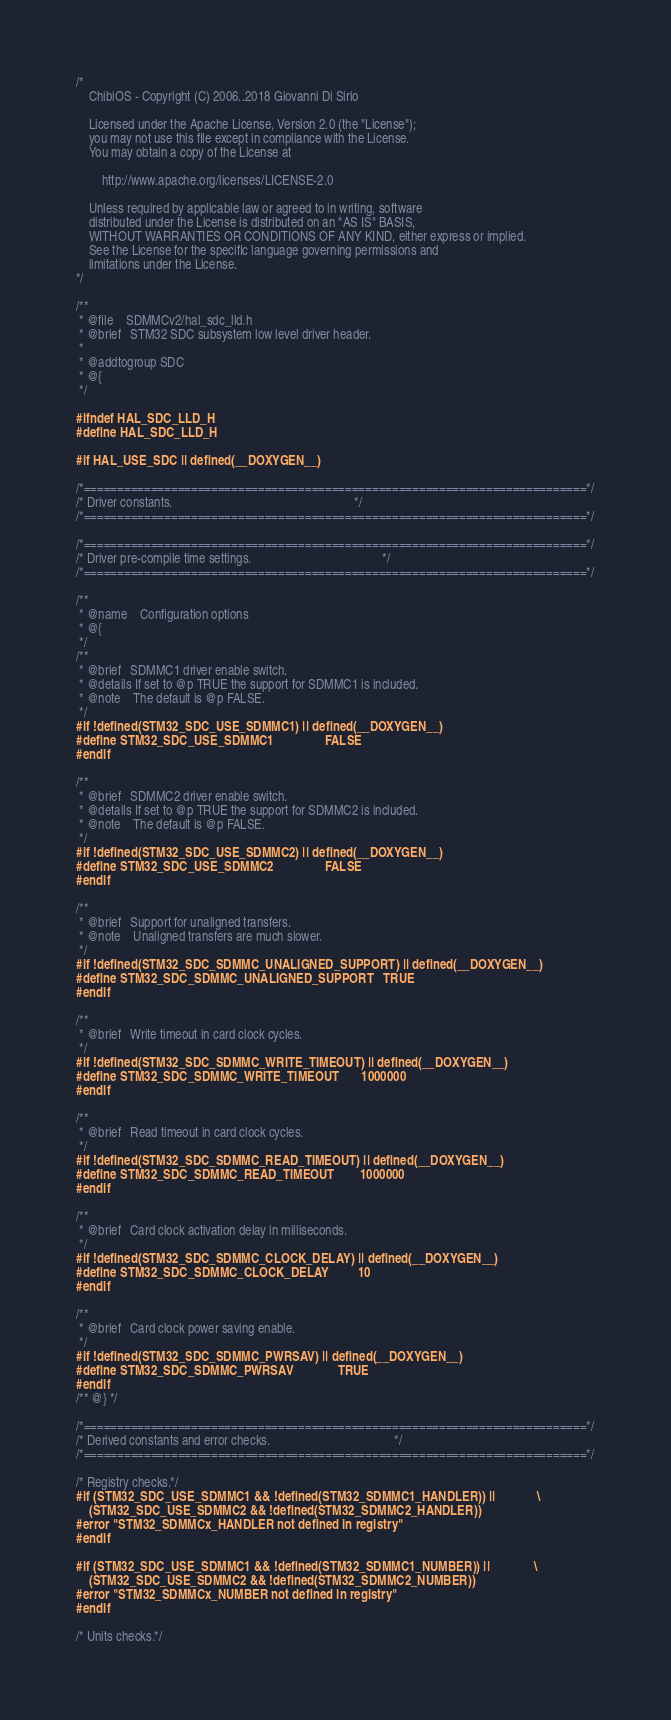Convert code to text. <code><loc_0><loc_0><loc_500><loc_500><_C_>/*
    ChibiOS - Copyright (C) 2006..2018 Giovanni Di Sirio

    Licensed under the Apache License, Version 2.0 (the "License");
    you may not use this file except in compliance with the License.
    You may obtain a copy of the License at

        http://www.apache.org/licenses/LICENSE-2.0

    Unless required by applicable law or agreed to in writing, software
    distributed under the License is distributed on an "AS IS" BASIS,
    WITHOUT WARRANTIES OR CONDITIONS OF ANY KIND, either express or implied.
    See the License for the specific language governing permissions and
    limitations under the License.
*/

/**
 * @file    SDMMCv2/hal_sdc_lld.h
 * @brief   STM32 SDC subsystem low level driver header.
 *
 * @addtogroup SDC
 * @{
 */

#ifndef HAL_SDC_LLD_H
#define HAL_SDC_LLD_H

#if HAL_USE_SDC || defined(__DOXYGEN__)

/*===========================================================================*/
/* Driver constants.                                                         */
/*===========================================================================*/

/*===========================================================================*/
/* Driver pre-compile time settings.                                         */
/*===========================================================================*/

/**
 * @name    Configuration options
 * @{
 */
/**
 * @brief   SDMMC1 driver enable switch.
 * @details If set to @p TRUE the support for SDMMC1 is included.
 * @note    The default is @p FALSE.
 */
#if !defined(STM32_SDC_USE_SDMMC1) || defined(__DOXYGEN__)
#define STM32_SDC_USE_SDMMC1                FALSE
#endif

/**
 * @brief   SDMMC2 driver enable switch.
 * @details If set to @p TRUE the support for SDMMC2 is included.
 * @note    The default is @p FALSE.
 */
#if !defined(STM32_SDC_USE_SDMMC2) || defined(__DOXYGEN__)
#define STM32_SDC_USE_SDMMC2                FALSE
#endif

/**
 * @brief   Support for unaligned transfers.
 * @note    Unaligned transfers are much slower.
 */
#if !defined(STM32_SDC_SDMMC_UNALIGNED_SUPPORT) || defined(__DOXYGEN__)
#define STM32_SDC_SDMMC_UNALIGNED_SUPPORT   TRUE
#endif

/**
 * @brief   Write timeout in card clock cycles.
 */
#if !defined(STM32_SDC_SDMMC_WRITE_TIMEOUT) || defined(__DOXYGEN__)
#define STM32_SDC_SDMMC_WRITE_TIMEOUT       1000000
#endif

/**
 * @brief   Read timeout in card clock cycles.
 */
#if !defined(STM32_SDC_SDMMC_READ_TIMEOUT) || defined(__DOXYGEN__)
#define STM32_SDC_SDMMC_READ_TIMEOUT        1000000
#endif

/**
 * @brief   Card clock activation delay in milliseconds.
 */
#if !defined(STM32_SDC_SDMMC_CLOCK_DELAY) || defined(__DOXYGEN__)
#define STM32_SDC_SDMMC_CLOCK_DELAY         10
#endif

/**
 * @brief   Card clock power saving enable.
 */
#if !defined(STM32_SDC_SDMMC_PWRSAV) || defined(__DOXYGEN__)
#define STM32_SDC_SDMMC_PWRSAV              TRUE
#endif
/** @} */

/*===========================================================================*/
/* Derived constants and error checks.                                       */
/*===========================================================================*/

/* Registry checks.*/
#if (STM32_SDC_USE_SDMMC1 && !defined(STM32_SDMMC1_HANDLER)) ||             \
    (STM32_SDC_USE_SDMMC2 && !defined(STM32_SDMMC2_HANDLER))
#error "STM32_SDMMCx_HANDLER not defined in registry"
#endif

#if (STM32_SDC_USE_SDMMC1 && !defined(STM32_SDMMC1_NUMBER)) ||              \
    (STM32_SDC_USE_SDMMC2 && !defined(STM32_SDMMC2_NUMBER))
#error "STM32_SDMMCx_NUMBER not defined in registry"
#endif

/* Units checks.*/</code> 